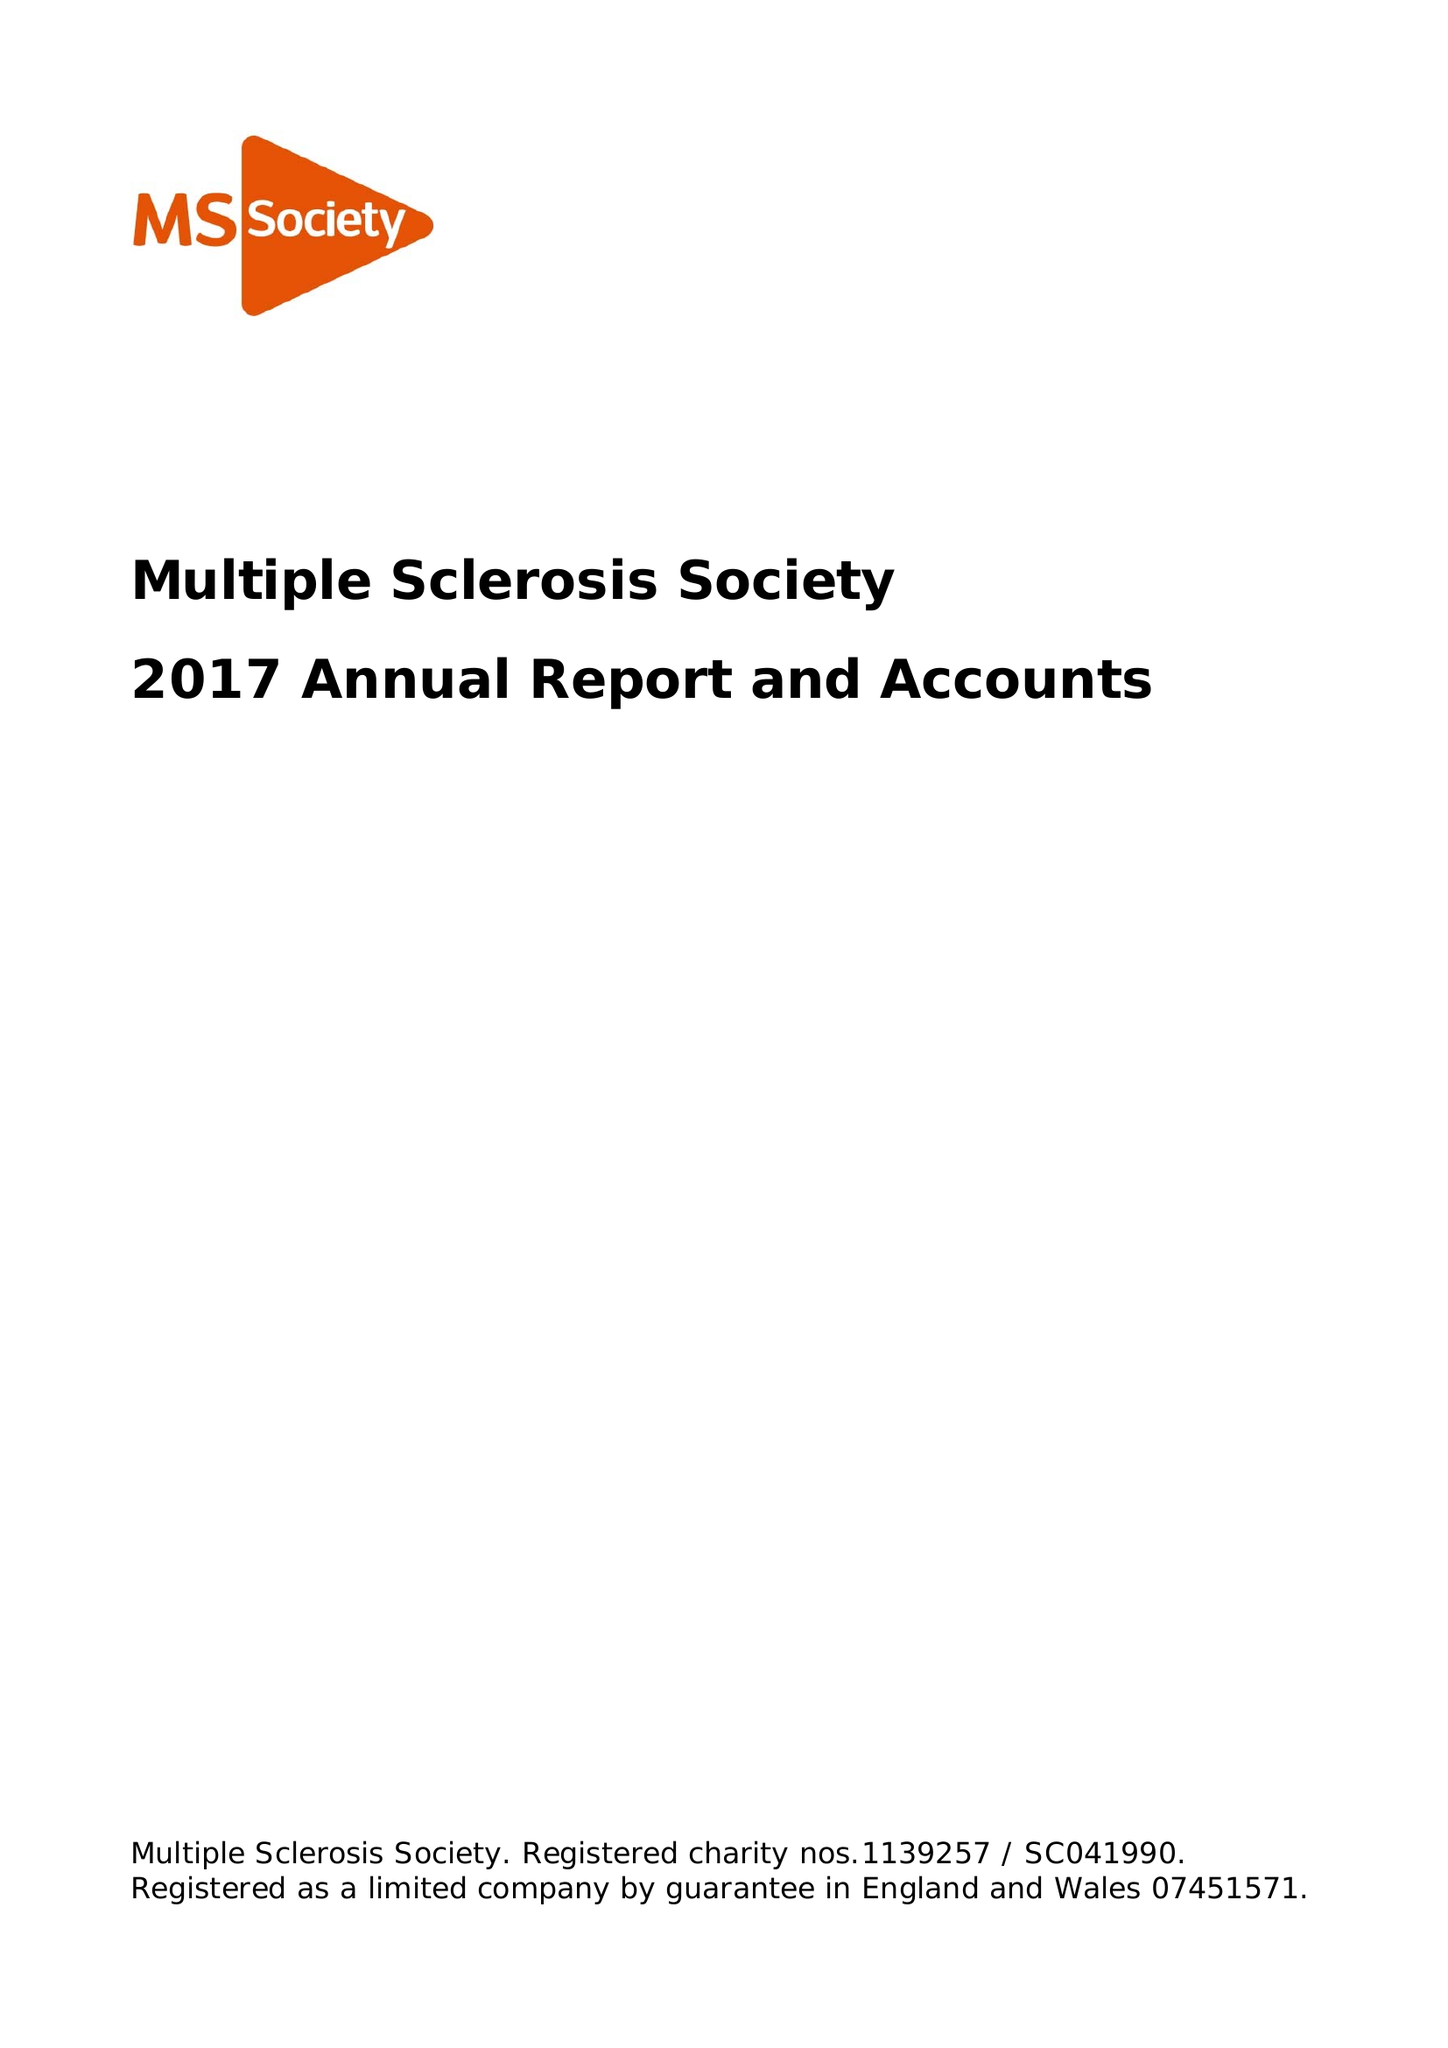What is the value for the charity_name?
Answer the question using a single word or phrase. Multiple Sclerosis Society 